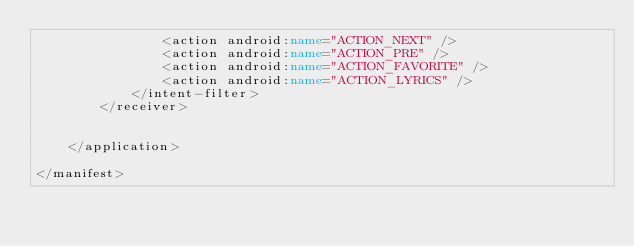Convert code to text. <code><loc_0><loc_0><loc_500><loc_500><_XML_>                <action android:name="ACTION_NEXT" />
                <action android:name="ACTION_PRE" />
                <action android:name="ACTION_FAVORITE" />
                <action android:name="ACTION_LYRICS" />
            </intent-filter>
        </receiver>


    </application>

</manifest></code> 